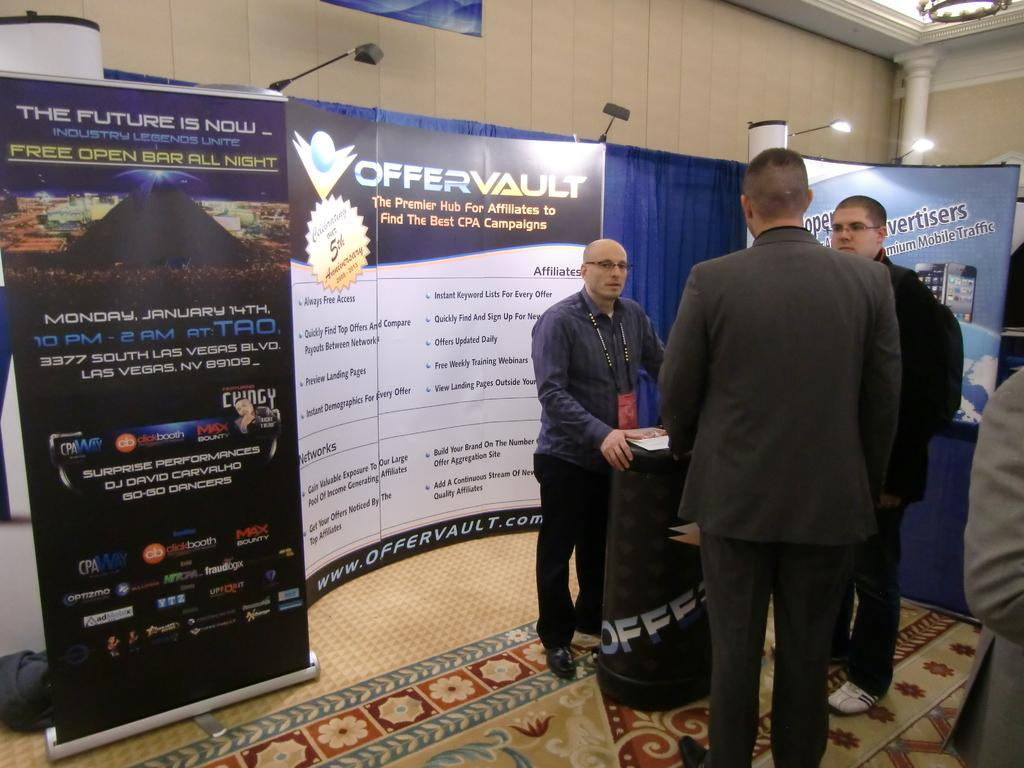What can be seen in the background of the image? There is a wall and a pillar in the background of the image. What type of advertisement or information might be displayed on the hoarding boards in the image? The hoarding boards in the image might display advertisements or information. What is located at the top of the image? There are lights at the top of the image. What is the surface that people are standing on in the image? People are standing on the floor in the image. What type of gun is being used by the person in the image? There is no person or gun present in the image. How does the behavior of the people in the image change throughout the day? The image does not show any changes in behavior, as it is a still image. 